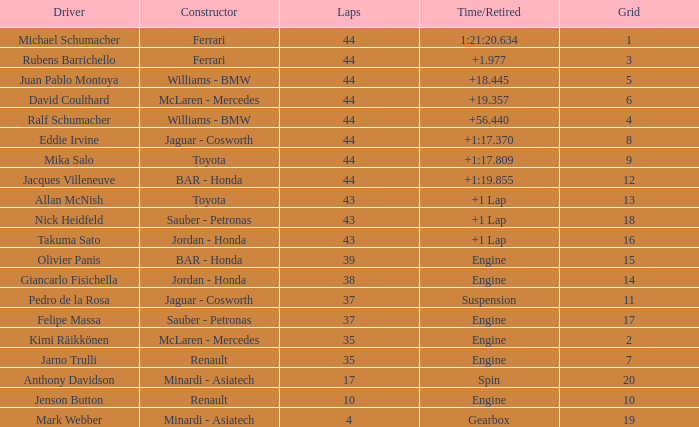What was the retired time on someone who had 43 laps on a grip of 18? +1 Lap. 